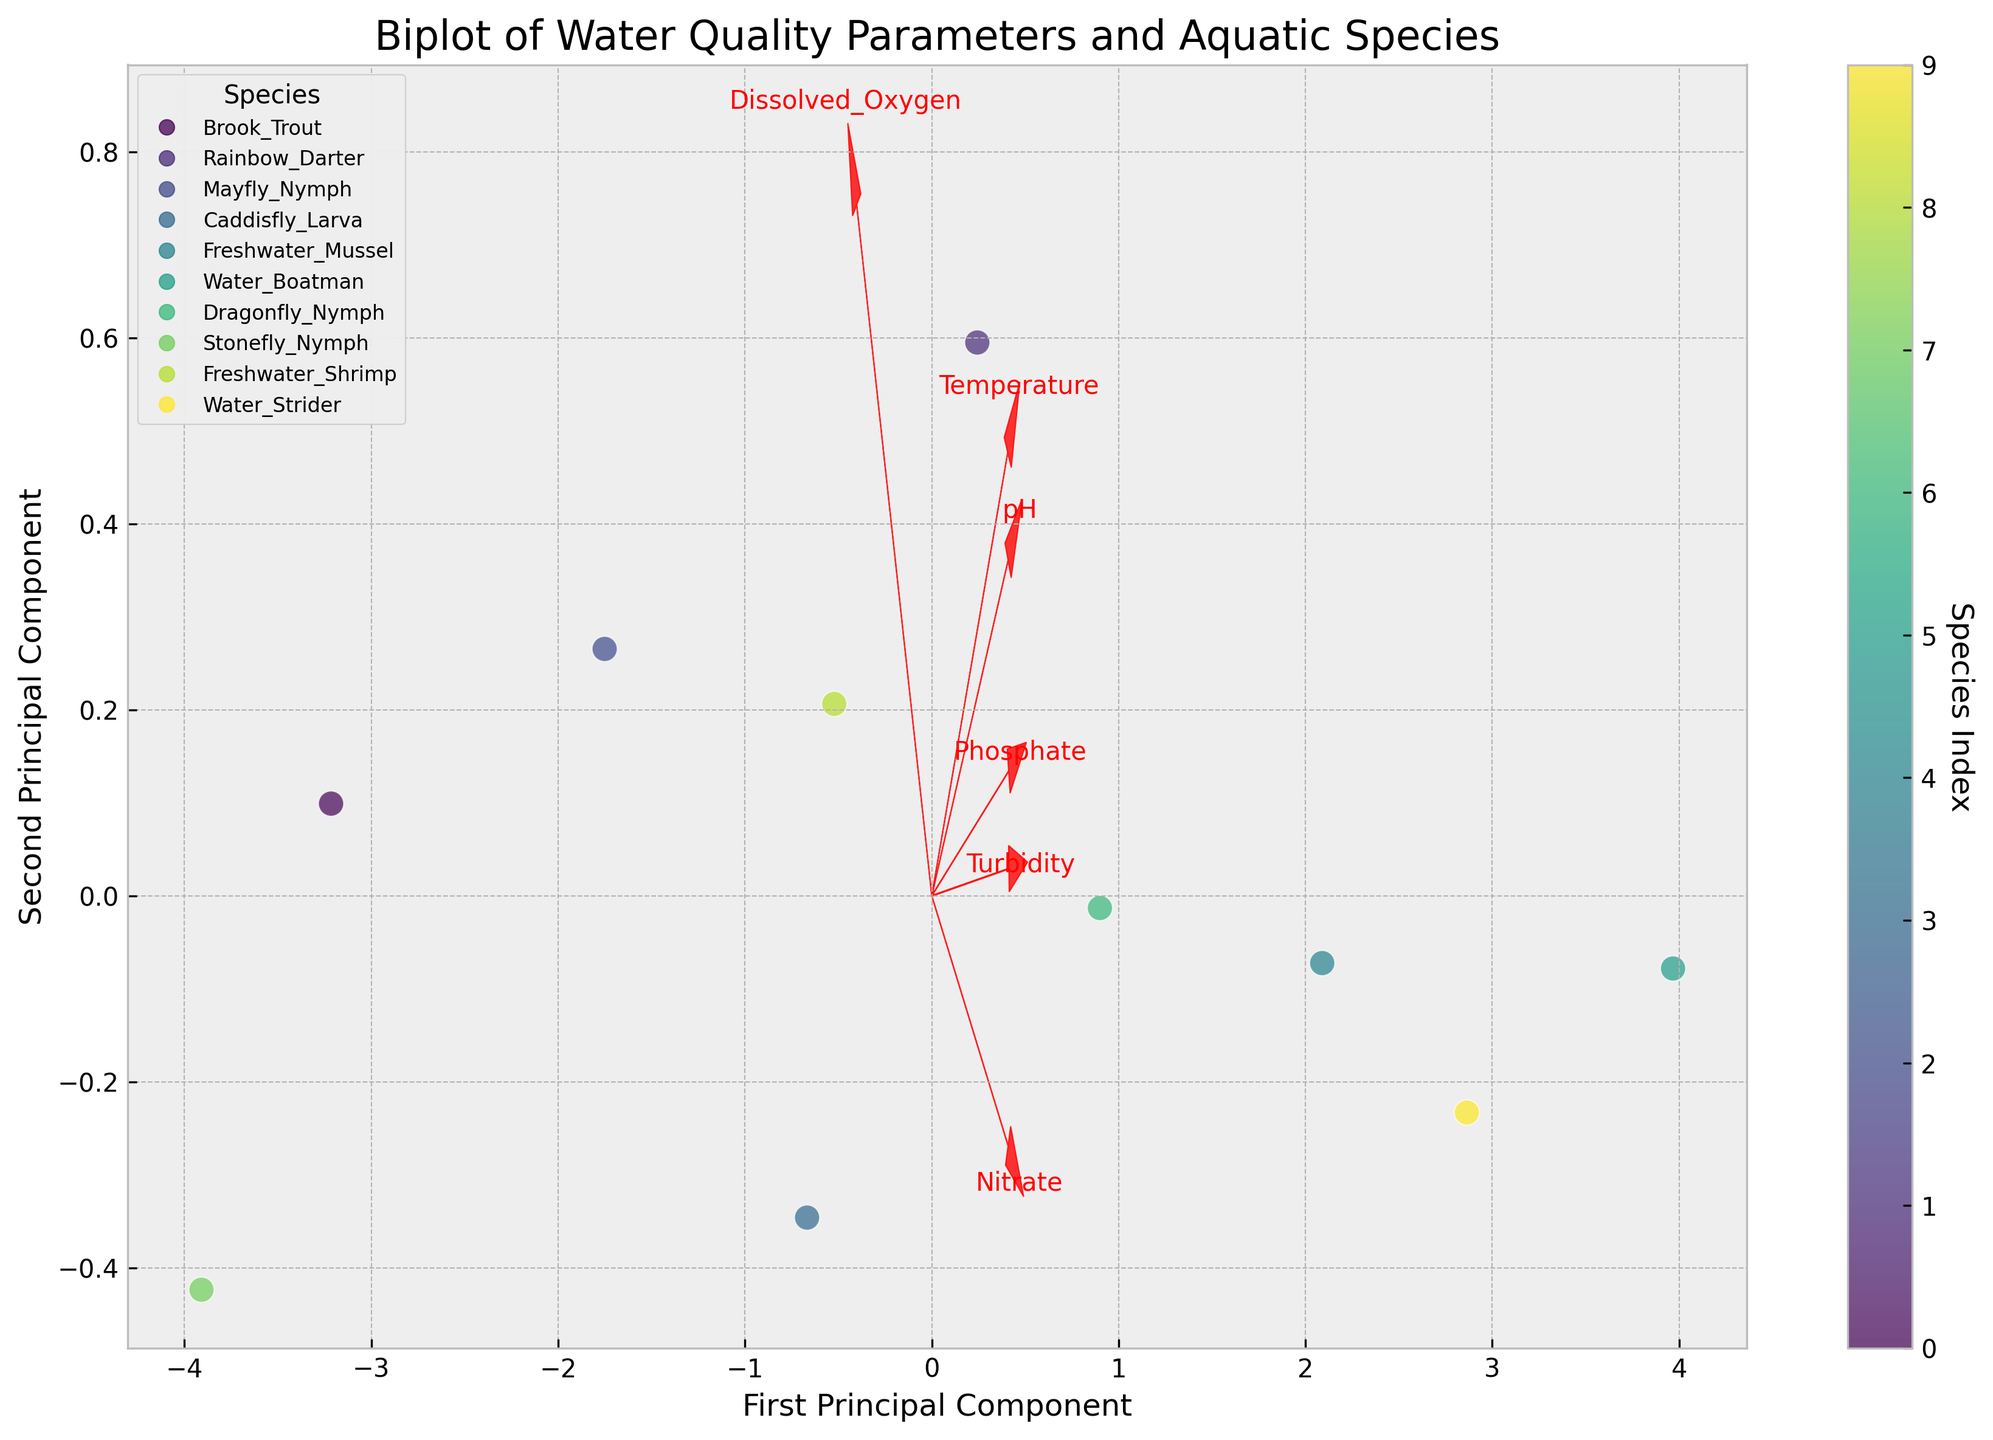What's the title of the figure? The title is typically displayed at the top of the figure, usually in larger, bold font. In this case, it reads "Biplot of Water Quality Parameters and Aquatic Species".
Answer: Biplot of Water Quality Parameters and Aquatic Species What are the labels of the principal components on the axes? The principal component labels are generally displayed along the axes in biplots. Here, the x-axis is labeled 'First Principal Component' and the y-axis is labeled 'Second Principal Component'.
Answer: First Principal Component, Second Principal Component How many data points are plotted in the figure? Each species is represented as one data point in the scatter plot. Counting the number of species in the legend gives us the total data points. There are 10 species listed.
Answer: 10 Which water quality parameter has the largest vector in the direction of the first principal component? By examining the direction and length of the arrows representing each water quality parameter, the parameter whose arrow extends the farthest along the x-axis (first principal component) is the one with the largest vector. It looks like 'Temperature' has the largest extent.
Answer: Temperature Which two species are closest to each other in the biplot? To find the closest species, look for the two data points (species) that are nearest each other in the plot. 'Rainbow Darter' and 'Dragonfly Nymph' appear to be the closest.
Answer: Rainbow Darter and Dragonfly Nymph Which water quality parameter is most positively correlated with 'pH' based on the direction of the vectors? Parameters that have vectors pointing in similar directions are positively correlated. Looking at the plot, both 'pH' and 'Temperature' vectors point in a similar direction.
Answer: Temperature Is 'Nitrate' more closely associated with higher or lower 'Dissolved Oxygen'? Look at the vectors for 'Nitrate' and 'Dissolved Oxygen'. Since their vectors point in almost opposite directions, 'Nitrate' is more closely associated with lower 'Dissolved Oxygen'.
Answer: Lower Dissolved Oxygen What is the approximate range of scores along the first principal component axis? To identify the range, examine the minimum and maximum x-axis values where the data points (species) are located. The points range approximately from -2 to 3 on the first principal component.
Answer: -2 to 3 Which water quality parameter has the smallest impact on the second principal component? Identify which parameter vector has the smallest displacement along the y-axis (second principal component). The 'pH' vector has the smallest extent upwards or downwards.
Answer: pH Among 'Freshwater Mussel' and 'Water Strider', which is associated with lower 'Turbidity'? Compare the locations of 'Freshwater Mussel' and 'Water Strider' with reference to the 'Turbidity' vector. 'Freshwater Mussel' is closer to the origin along the 'Turbidity' vector, indicating lower 'Turbidity' values.
Answer: Freshwater Mussel 